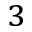<formula> <loc_0><loc_0><loc_500><loc_500>_ { 3 }</formula> 